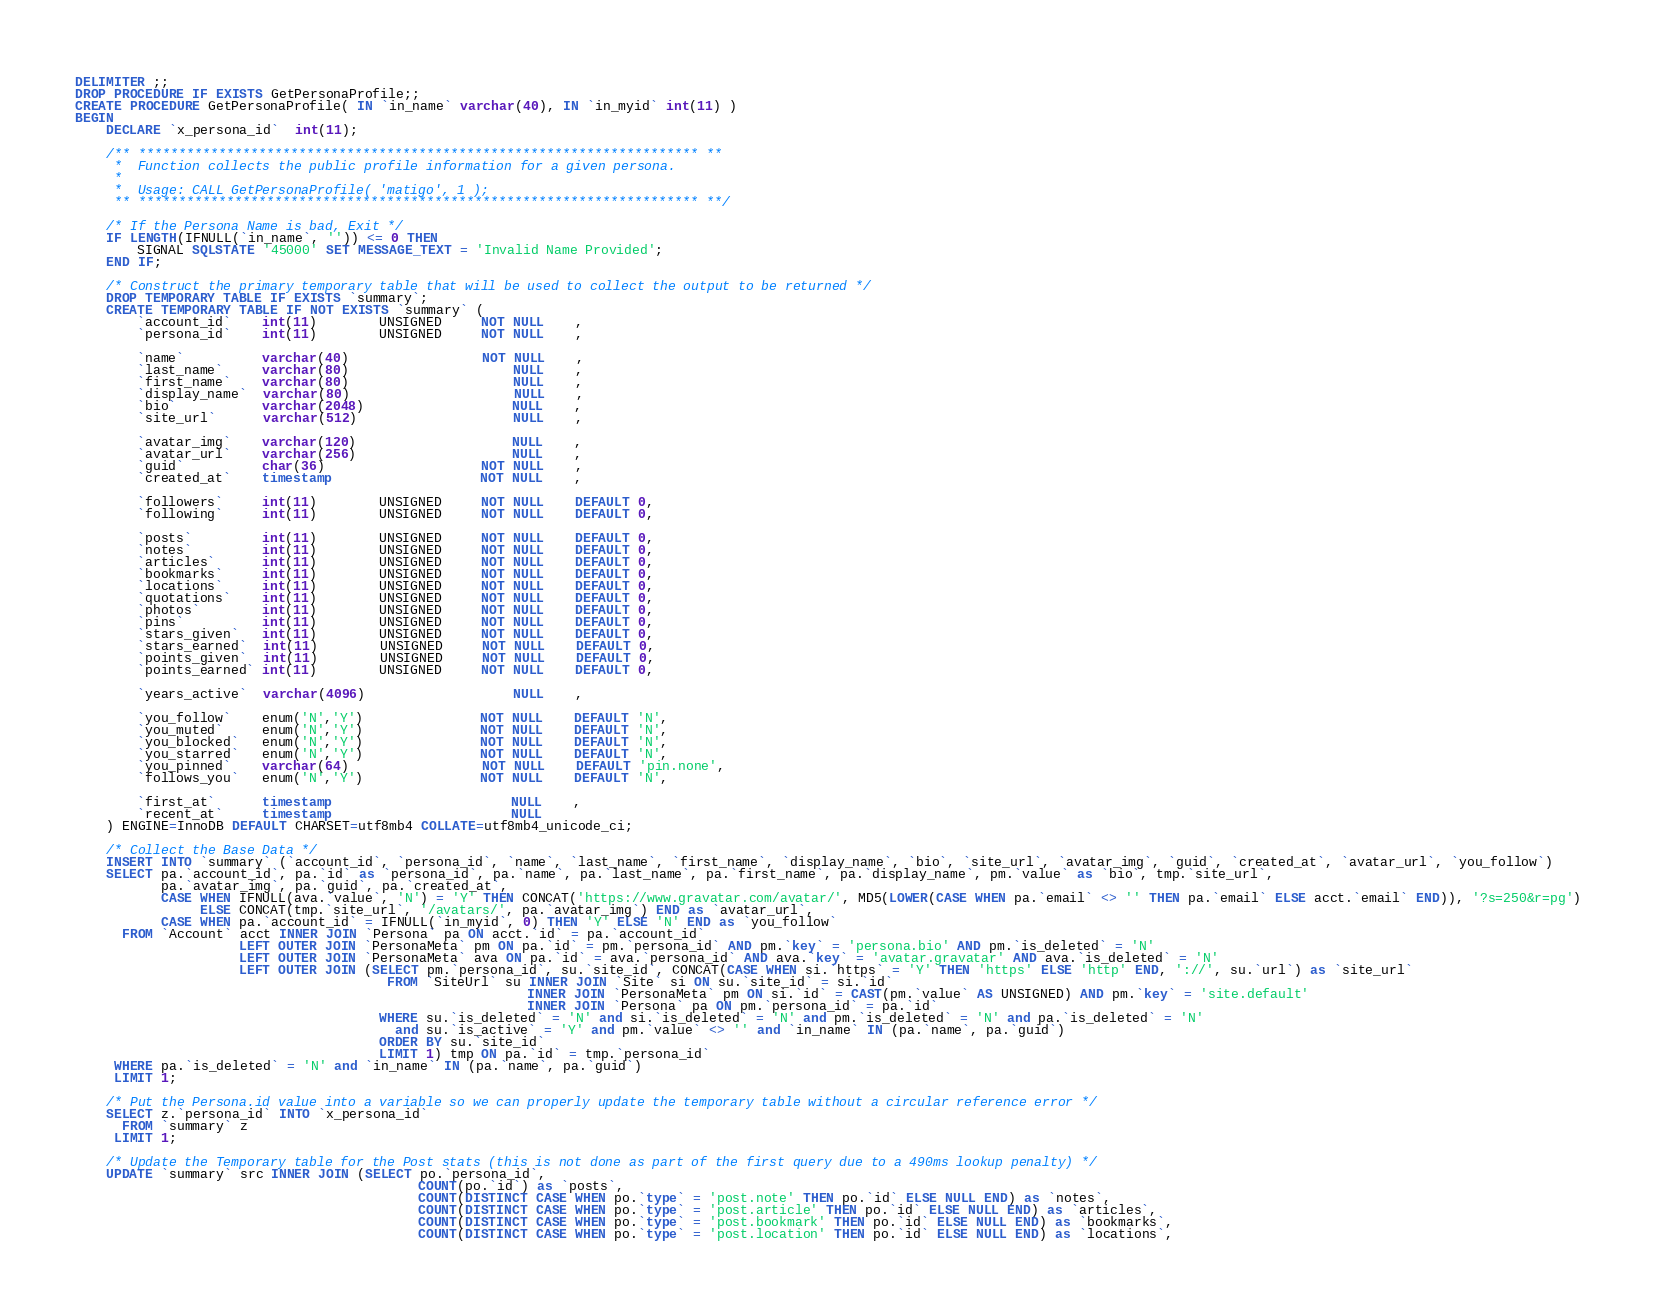Convert code to text. <code><loc_0><loc_0><loc_500><loc_500><_SQL_>DELIMITER ;;
DROP PROCEDURE IF EXISTS GetPersonaProfile;;
CREATE PROCEDURE GetPersonaProfile( IN `in_name` varchar(40), IN `in_myid` int(11) )
BEGIN
    DECLARE `x_persona_id`  int(11);

    /** ********************************************************************** **
     *  Function collects the public profile information for a given persona.
     *
     *  Usage: CALL GetPersonaProfile( 'matigo', 1 );
     ** ********************************************************************** **/

    /* If the Persona Name is bad, Exit */
    IF LENGTH(IFNULL(`in_name`, '')) <= 0 THEN
        SIGNAL SQLSTATE '45000' SET MESSAGE_TEXT = 'Invalid Name Provided';
    END IF;

    /* Construct the primary temporary table that will be used to collect the output to be returned */
    DROP TEMPORARY TABLE IF EXISTS `summary`;
    CREATE TEMPORARY TABLE IF NOT EXISTS `summary` (
        `account_id`    int(11)        UNSIGNED     NOT NULL    ,
        `persona_id`    int(11)        UNSIGNED     NOT NULL    ,

        `name`          varchar(40)                 NOT NULL    ,
        `last_name`     varchar(80)                     NULL    ,
        `first_name`    varchar(80)                     NULL    ,
        `display_name`  varchar(80)                     NULL    ,
        `bio`           varchar(2048)                   NULL    ,
        `site_url`      varchar(512)                    NULL    ,

        `avatar_img`    varchar(120)                    NULL    ,
        `avatar_url`    varchar(256)                    NULL    ,
        `guid`          char(36)                    NOT NULL    ,
        `created_at`    timestamp                   NOT NULL    ,

        `followers`     int(11)        UNSIGNED     NOT NULL    DEFAULT 0,
        `following`     int(11)        UNSIGNED     NOT NULL    DEFAULT 0,

        `posts`         int(11)        UNSIGNED     NOT NULL    DEFAULT 0,
        `notes`         int(11)        UNSIGNED     NOT NULL    DEFAULT 0,
        `articles`      int(11)        UNSIGNED     NOT NULL    DEFAULT 0,
        `bookmarks`     int(11)        UNSIGNED     NOT NULL    DEFAULT 0,
        `locations`     int(11)        UNSIGNED     NOT NULL    DEFAULT 0,
        `quotations`    int(11)        UNSIGNED     NOT NULL    DEFAULT 0,
        `photos`        int(11)        UNSIGNED     NOT NULL    DEFAULT 0,
        `pins`          int(11)        UNSIGNED     NOT NULL    DEFAULT 0,
        `stars_given`   int(11)        UNSIGNED     NOT NULL    DEFAULT 0,
        `stars_earned`  int(11)        UNSIGNED     NOT NULL    DEFAULT 0,
        `points_given`  int(11)        UNSIGNED     NOT NULL    DEFAULT 0,
        `points_earned` int(11)        UNSIGNED     NOT NULL    DEFAULT 0,

        `years_active`  varchar(4096)                   NULL    ,

        `you_follow`    enum('N','Y')               NOT NULL    DEFAULT 'N',
        `you_muted`     enum('N','Y')               NOT NULL    DEFAULT 'N',
        `you_blocked`   enum('N','Y')               NOT NULL    DEFAULT 'N',
        `you_starred`   enum('N','Y')               NOT NULL    DEFAULT 'N',
        `you_pinned`    varchar(64)                 NOT NULL    DEFAULT 'pin.none',
        `follows_you`   enum('N','Y')               NOT NULL    DEFAULT 'N',

        `first_at`      timestamp                       NULL    ,
        `recent_at`     timestamp                       NULL
    ) ENGINE=InnoDB DEFAULT CHARSET=utf8mb4 COLLATE=utf8mb4_unicode_ci;

    /* Collect the Base Data */
    INSERT INTO `summary` (`account_id`, `persona_id`, `name`, `last_name`, `first_name`, `display_name`, `bio`, `site_url`, `avatar_img`, `guid`, `created_at`, `avatar_url`, `you_follow`)
    SELECT pa.`account_id`, pa.`id` as `persona_id`, pa.`name`, pa.`last_name`, pa.`first_name`, pa.`display_name`, pm.`value` as `bio`, tmp.`site_url`,
           pa.`avatar_img`, pa.`guid`, pa.`created_at`,
           CASE WHEN IFNULL(ava.`value`, 'N') = 'Y' THEN CONCAT('https://www.gravatar.com/avatar/', MD5(LOWER(CASE WHEN pa.`email` <> '' THEN pa.`email` ELSE acct.`email` END)), '?s=250&r=pg')
                ELSE CONCAT(tmp.`site_url`, '/avatars/', pa.`avatar_img`) END as `avatar_url`,
           CASE WHEN pa.`account_id` = IFNULL(`in_myid`, 0) THEN 'Y' ELSE 'N' END as `you_follow`
      FROM `Account` acct INNER JOIN `Persona` pa ON acct.`id` = pa.`account_id`
                     LEFT OUTER JOIN `PersonaMeta` pm ON pa.`id` = pm.`persona_id` AND pm.`key` = 'persona.bio' AND pm.`is_deleted` = 'N'
                     LEFT OUTER JOIN `PersonaMeta` ava ON pa.`id` = ava.`persona_id` AND ava.`key` = 'avatar.gravatar' AND ava.`is_deleted` = 'N'
                     LEFT OUTER JOIN (SELECT pm.`persona_id`, su.`site_id`, CONCAT(CASE WHEN si.`https` = 'Y' THEN 'https' ELSE 'http' END, '://', su.`url`) as `site_url`
                                        FROM `SiteUrl` su INNER JOIN `Site` si ON su.`site_id` = si.`id`
                                                          INNER JOIN `PersonaMeta` pm ON si.`id` = CAST(pm.`value` AS UNSIGNED) AND pm.`key` = 'site.default'
                                                          INNER JOIN `Persona` pa ON pm.`persona_id` = pa.`id`
                                       WHERE su.`is_deleted` = 'N' and si.`is_deleted` = 'N' and pm.`is_deleted` = 'N' and pa.`is_deleted` = 'N'
                                         and su.`is_active` = 'Y' and pm.`value` <> '' and `in_name` IN (pa.`name`, pa.`guid`)
                                       ORDER BY su.`site_id`
                                       LIMIT 1) tmp ON pa.`id` = tmp.`persona_id`
     WHERE pa.`is_deleted` = 'N' and `in_name` IN (pa.`name`, pa.`guid`)
     LIMIT 1;

    /* Put the Persona.id value into a variable so we can properly update the temporary table without a circular reference error */
    SELECT z.`persona_id` INTO `x_persona_id`
      FROM `summary` z
     LIMIT 1;

    /* Update the Temporary table for the Post stats (this is not done as part of the first query due to a 490ms lookup penalty) */
    UPDATE `summary` src INNER JOIN (SELECT po.`persona_id`,
                                            COUNT(po.`id`) as `posts`,
                                            COUNT(DISTINCT CASE WHEN po.`type` = 'post.note' THEN po.`id` ELSE NULL END) as `notes`,
                                            COUNT(DISTINCT CASE WHEN po.`type` = 'post.article' THEN po.`id` ELSE NULL END) as `articles`,
                                            COUNT(DISTINCT CASE WHEN po.`type` = 'post.bookmark' THEN po.`id` ELSE NULL END) as `bookmarks`,
                                            COUNT(DISTINCT CASE WHEN po.`type` = 'post.location' THEN po.`id` ELSE NULL END) as `locations`,</code> 